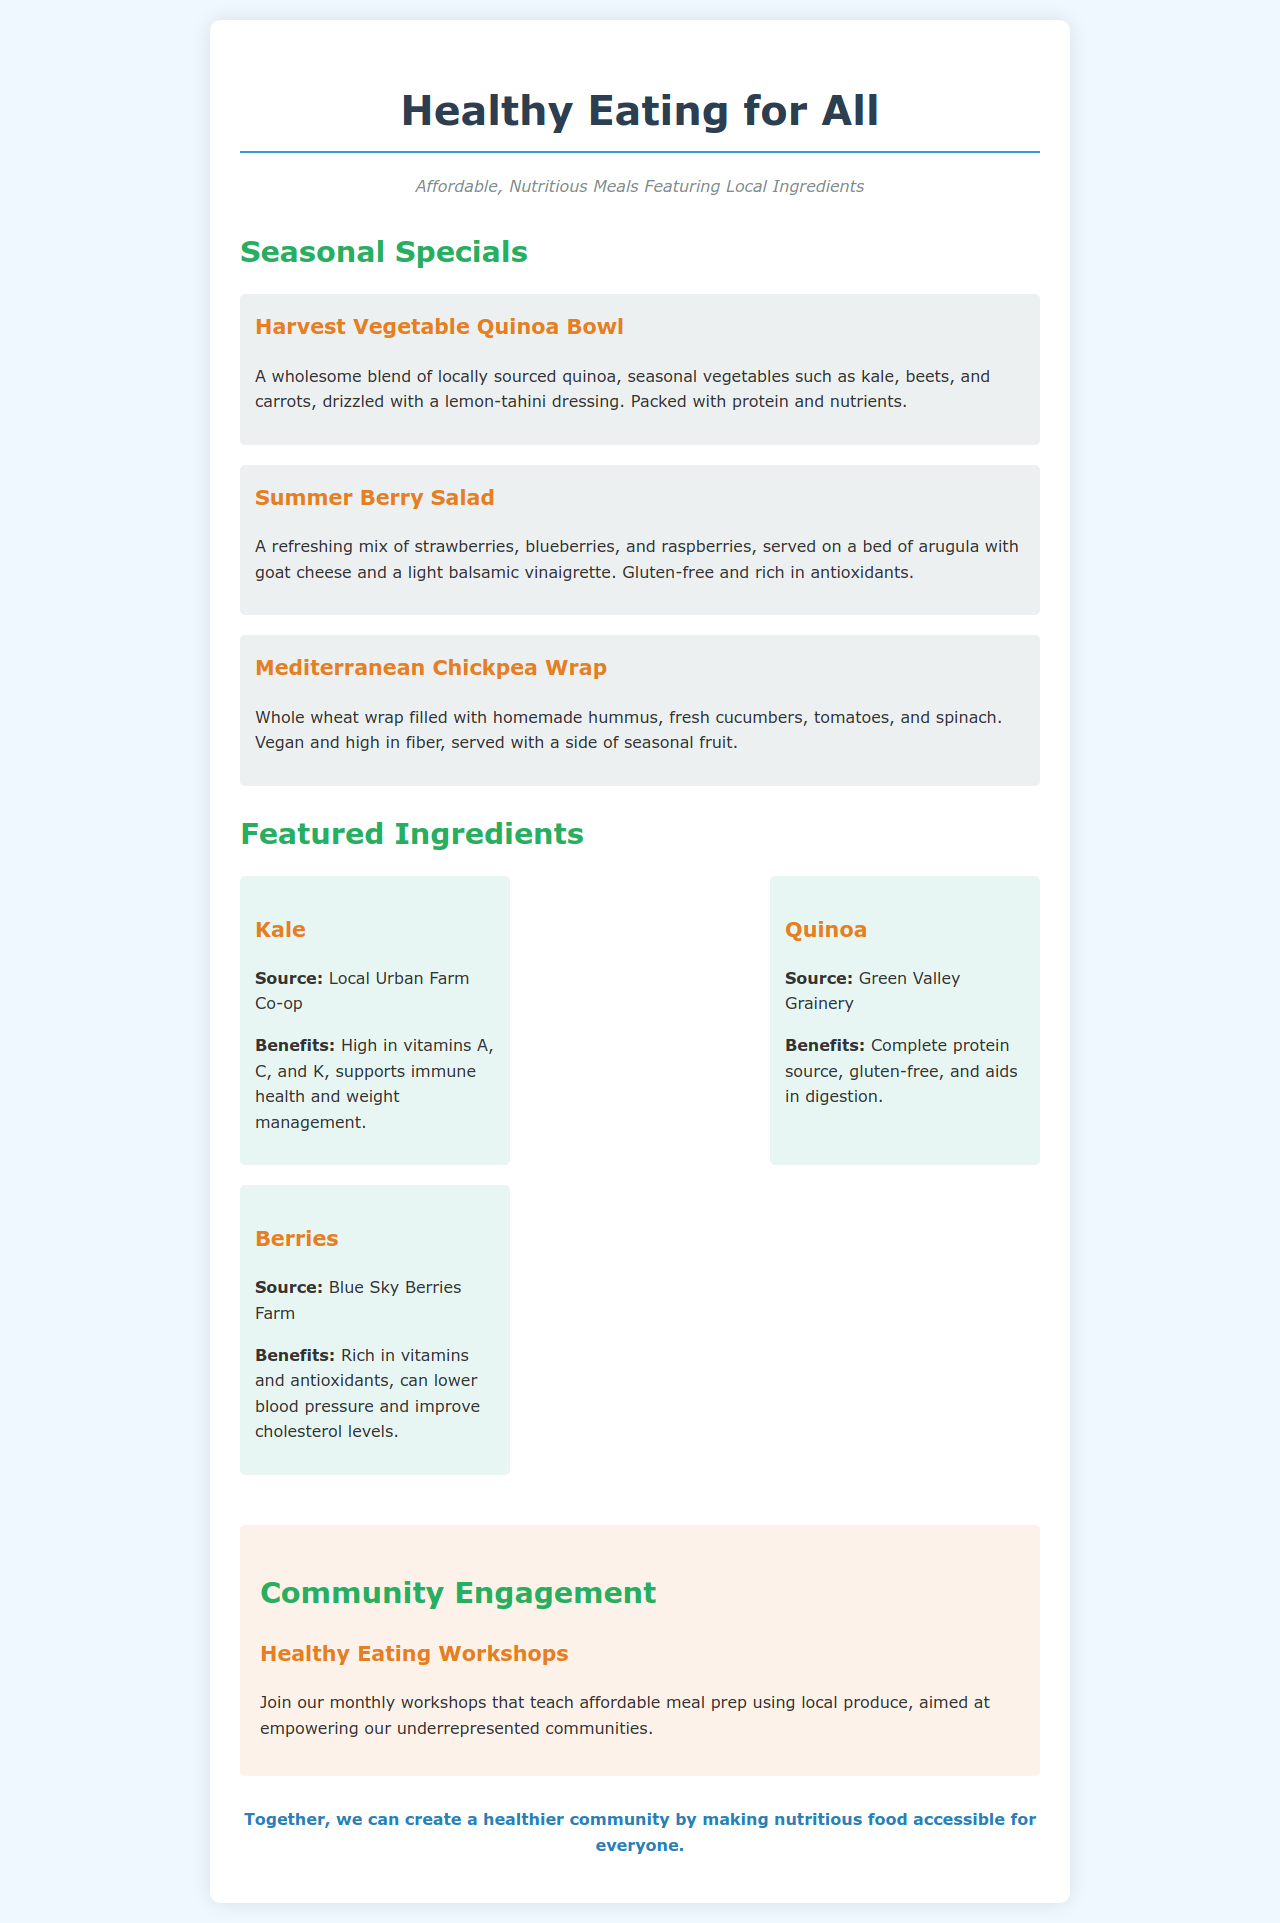What is the title of the menu? The title of the menu is displayed prominently at the top of the document.
Answer: Healthy Eating for All What is the first seasonal special listed? The first seasonal special is named in the section titled "Seasonal Specials."
Answer: Harvest Vegetable Quinoa Bowl What type of dressing is on the Harvest Vegetable Quinoa Bowl? The dressing for this dish is mentioned in its description.
Answer: Lemon-tahini dressing Which ingredient is featured as being gluten-free? The specific dietary information for the Mediterranean Chickpea Wrap indicates that it is suitable for gluten-free diets.
Answer: Gluten-free Where does the quinoa in the menu come from? The source of the quinoa is provided under the featured ingredients section.
Answer: Green Valley Grainery What type of workshops does the community engagement section mention? The workshops aimed at affordable meal prep are outlined in this section.
Answer: Healthy Eating Workshops How many menu items are included in the Seasonal Specials section? The total number of seasonal specials can be counted in that section.
Answer: Three What is one health benefit of kale listed in the menu? The benefits of kale are detailed under the featured ingredients section.
Answer: Supports immune health What color is used for the subtitle? The color of the subtitle is specified in the styling for that text.
Answer: Italic, grey color 